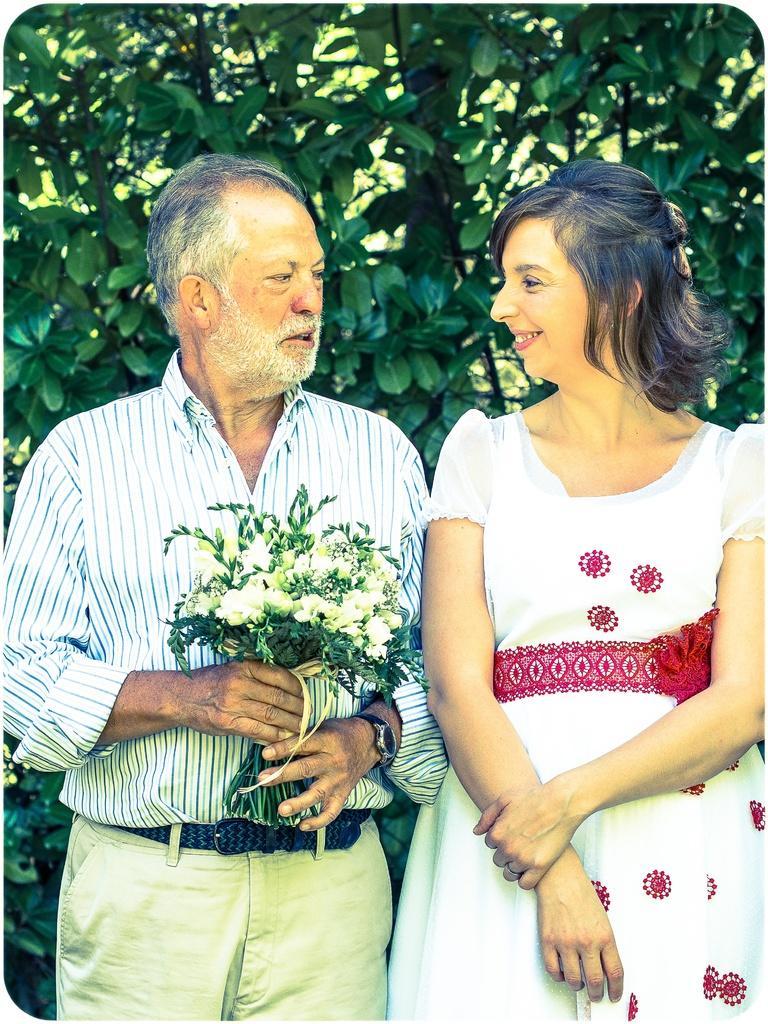In one or two sentences, can you explain what this image depicts? In this image in the foreground there is one man who is standing and he is holding a flower bouquet, on the right side there is one woman who is standing and smiling. In the background there are trees. 